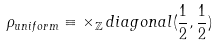Convert formula to latex. <formula><loc_0><loc_0><loc_500><loc_500>\rho _ { u n i f o r m } \equiv \times _ { { \mathbb { Z } } } \, d i a g o n a l ( \frac { 1 } { 2 } , \frac { 1 } { 2 } )</formula> 